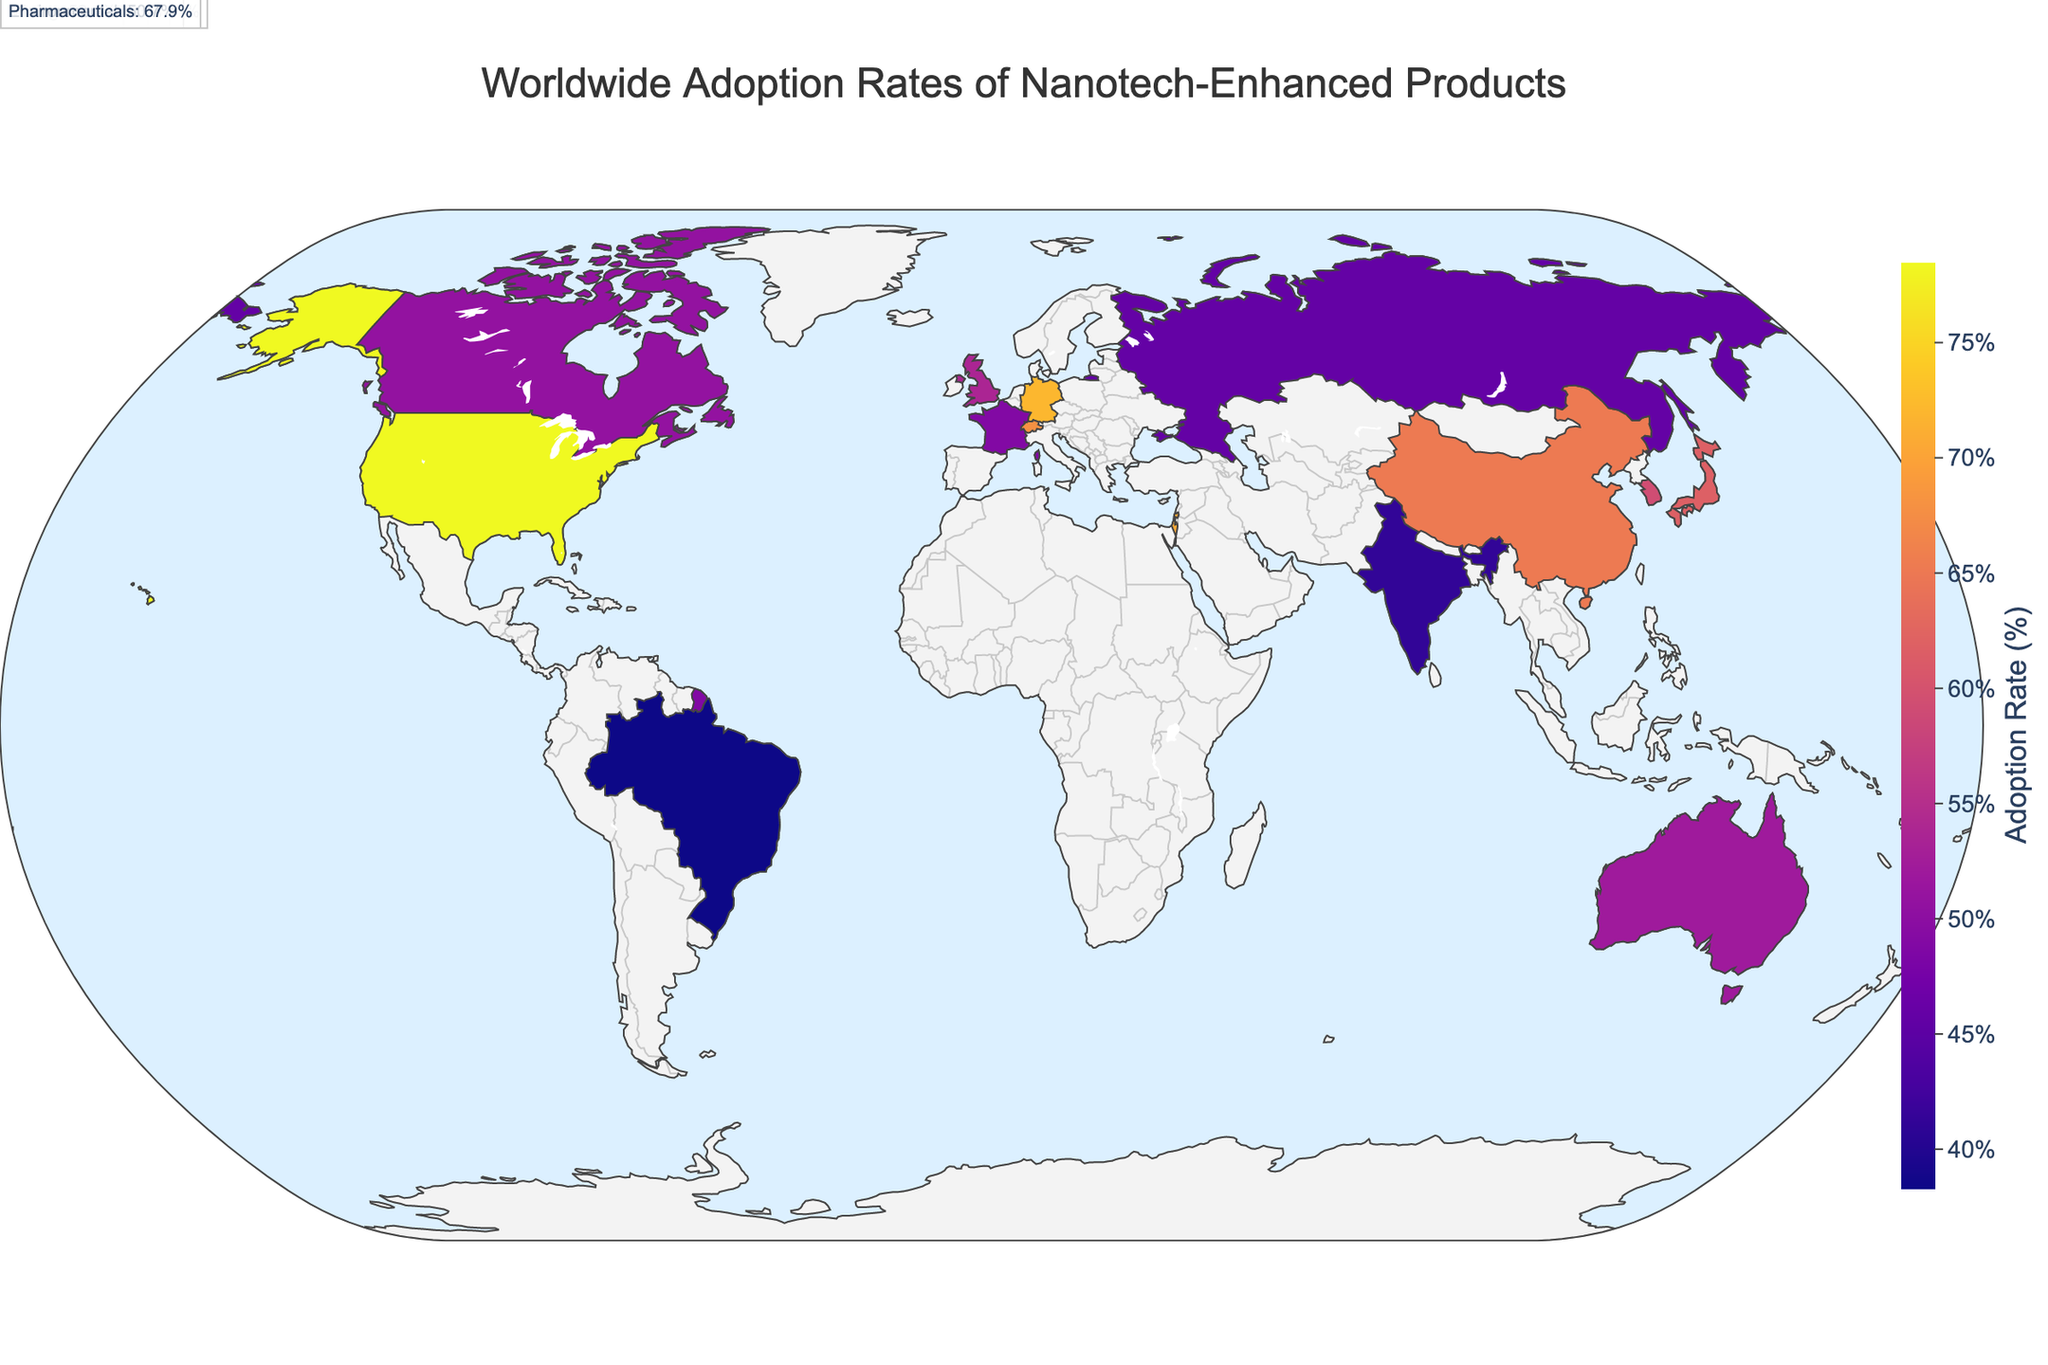What is the title of the figure? The title is directly displayed at the top of the figure and gives a summary of what the map represents.
Answer: Worldwide Adoption Rates of Nanotech-Enhanced Products Which country has the highest adoption rate and in which industry? Check the color intensity on the map and refer to the hover data to find the highest adoption rate. The United States has the darkest color and the highest adoption rate of 78.5% in Electronics.
Answer: United States, Electronics What is the average adoption rate across all listed countries? Sum the adoption rates of all countries and divide by the number of countries. The sum is 978.5 and there are 15 countries, so the average is 978.5/15.
Answer: 65.23% How do the adoption rates of nanotech-enhanced products in Energy and Consumer Goods industries compare? Locate Japan and the United Kingdom on the map. Observe that Japan (Energy) has an adoption rate of 61.8% and the United Kingdom (Consumer Goods) has an adoption rate of 53.7%.
Answer: Energy is higher at 61.8% Which countries have an adoption rate below 50%? Identify countries with light colors on the map indicating lower adoption rates. These countries are: France (48.9%), India (41.2%), Russia (45.8%), Brazil (38.3%).
Answer: France, India, Russia, Brazil What industry has the highest adoption rate in Germany and what is it? Locate Germany on the map. The hover data shows the industry (Automotive) with an adoption rate of 72.1%.
Answer: Automotive, 72.1% Which country in Asia has the lowest adoption rate and in which industry? Check the Asian countries on the map for the lowest adoption rate. India has the lowest adoption rate at 41.2% in Textiles.
Answer: India, Textiles How much higher is the adoption rate of nanotech-enhanced products in Aerospace compared to Water Treatment? Locate South Korea (Aerospace) and Singapore (Water Treatment) on the map. The adoption rate for Aerospace is 59.3% and for Water Treatment is 56.4%. Calculate the difference, 59.3 - 56.4.
Answer: 2.9% Which industry has an adoption rate closest to 70% and in which country? Check the hover data for adoption rates near 70%. Israel shows an adoption rate of 70.6% in Defense, which is closest.
Answer: Defense, Israel How many countries have an adoption rate above 60%? Count the countries on the map with dark enough colors indicating adoption rates above 60%: United States, China, Germany, Japan, Israel, Switzerland (6 countries).
Answer: 6 